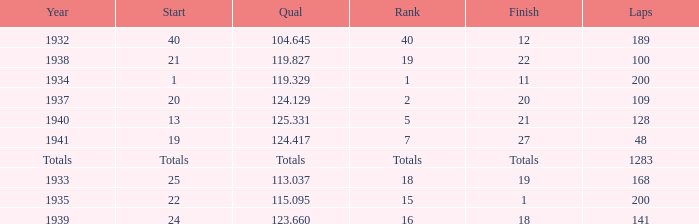What was the rank with the qual of 115.095? 15.0. 